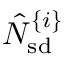Convert formula to latex. <formula><loc_0><loc_0><loc_500><loc_500>\hat { N } _ { s d } ^ { \{ i \} }</formula> 